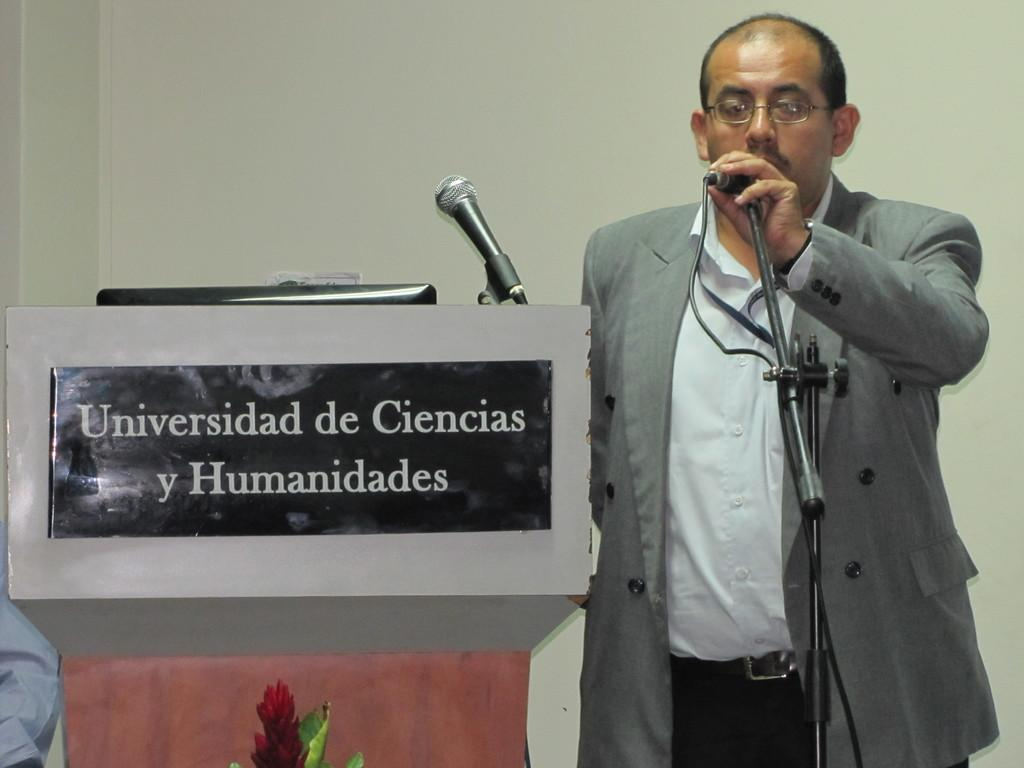What is the man in the image doing? The man is standing in the image and holding a microphone. What object is on the left side of the image? There is a podium on the left side of the image. What can be seen in the background of the image? There is a wall in the background of the image. What type of cloth is draped over the balloon in the image? There is no balloon or cloth present in the image. 